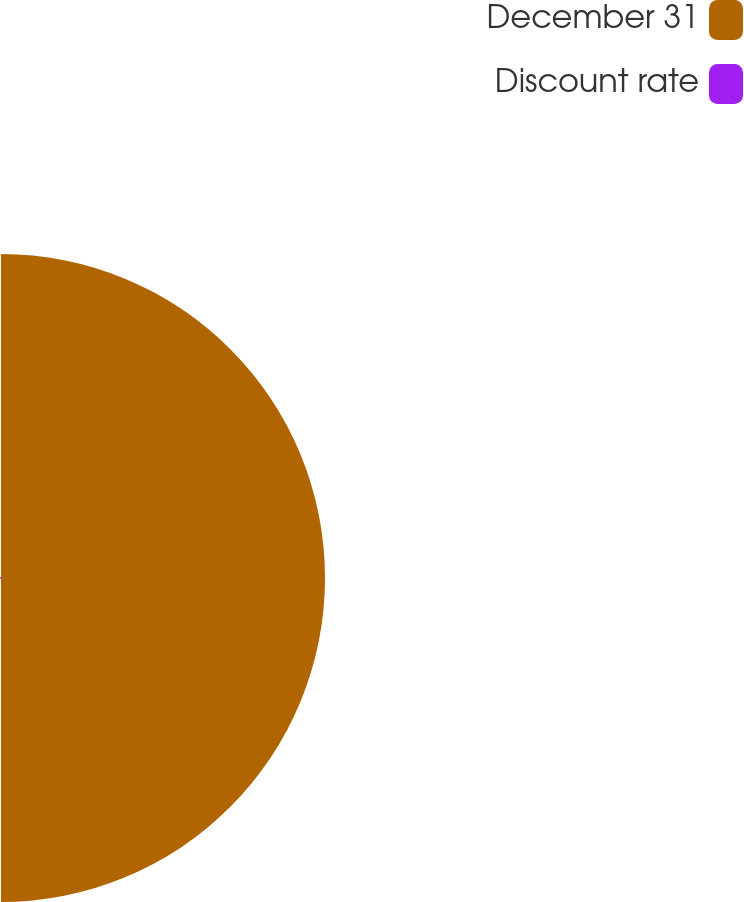<chart> <loc_0><loc_0><loc_500><loc_500><pie_chart><fcel>December 31<fcel>Discount rate<nl><fcel>99.7%<fcel>0.3%<nl></chart> 